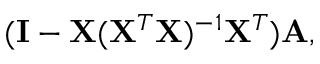Convert formula to latex. <formula><loc_0><loc_0><loc_500><loc_500>( I - X ( X ^ { T } X ) ^ { - 1 } X ^ { T } ) A ,</formula> 